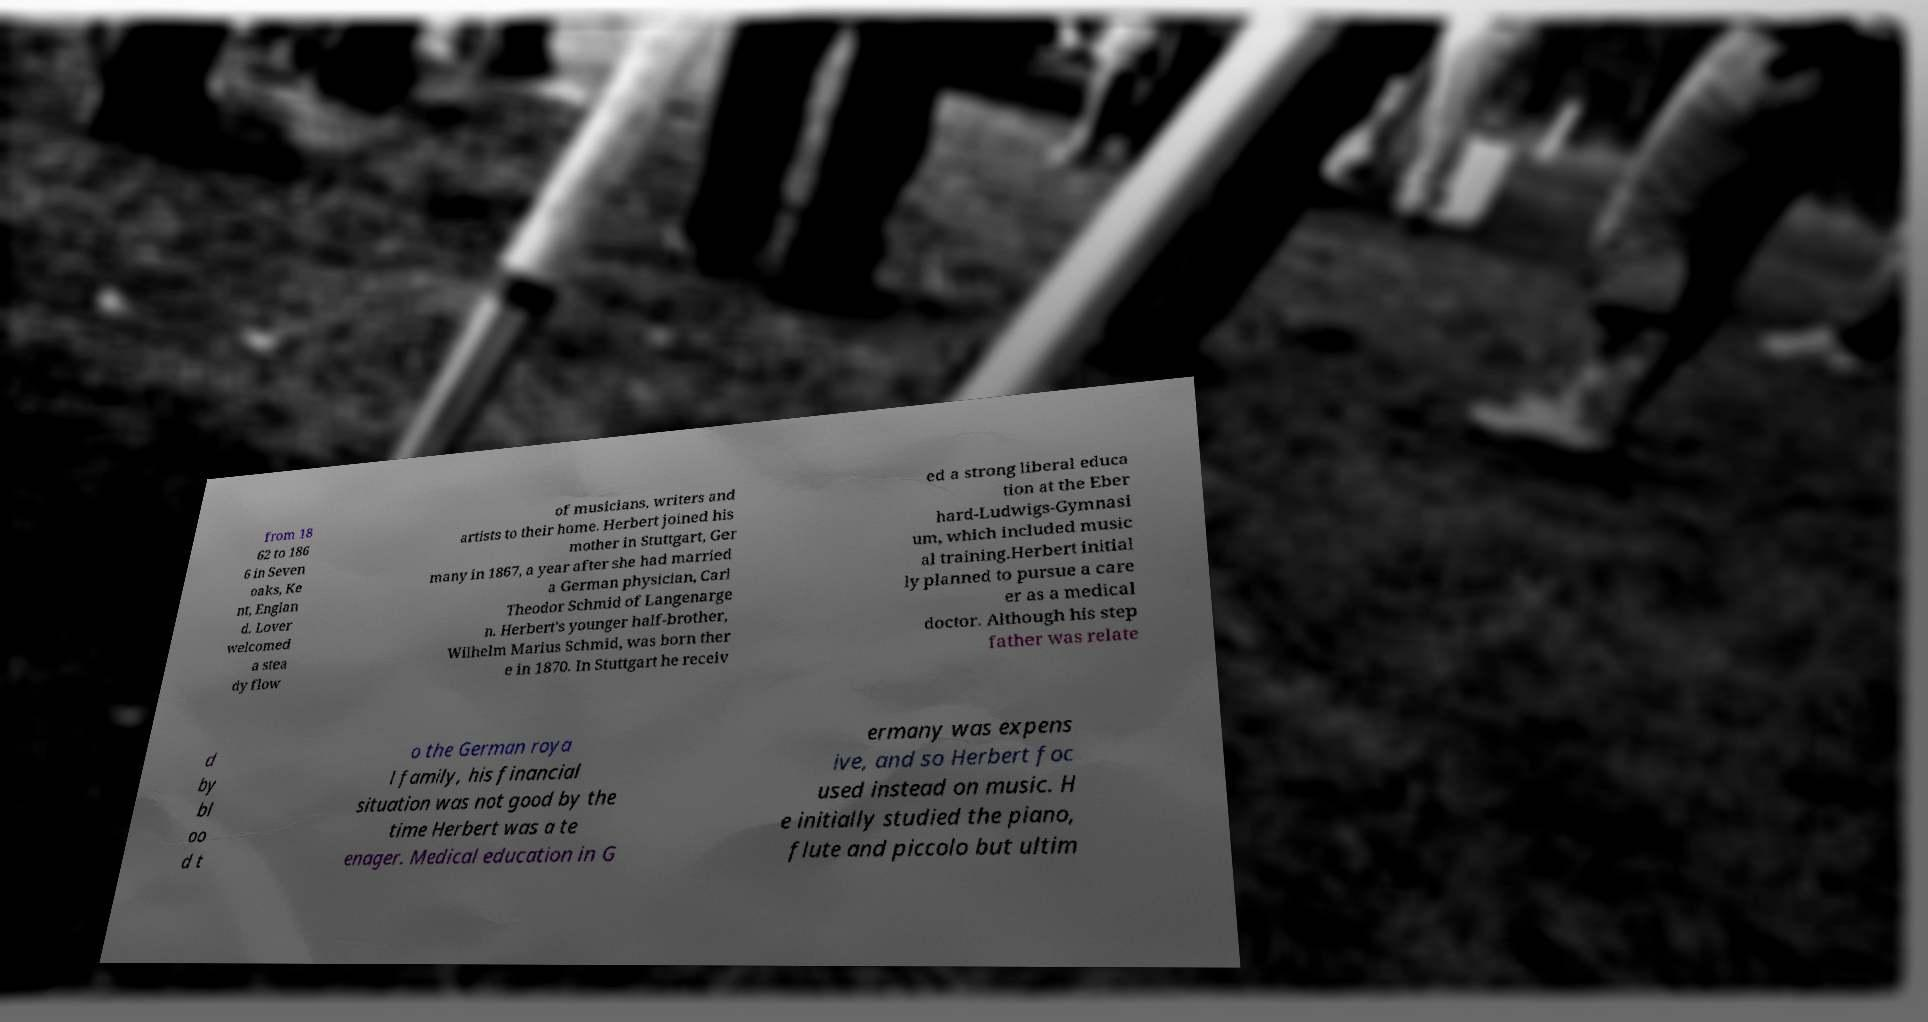What messages or text are displayed in this image? I need them in a readable, typed format. from 18 62 to 186 6 in Seven oaks, Ke nt, Englan d. Lover welcomed a stea dy flow of musicians, writers and artists to their home. Herbert joined his mother in Stuttgart, Ger many in 1867, a year after she had married a German physician, Carl Theodor Schmid of Langenarge n. Herbert's younger half-brother, Wilhelm Marius Schmid, was born ther e in 1870. In Stuttgart he receiv ed a strong liberal educa tion at the Eber hard-Ludwigs-Gymnasi um, which included music al training.Herbert initial ly planned to pursue a care er as a medical doctor. Although his step father was relate d by bl oo d t o the German roya l family, his financial situation was not good by the time Herbert was a te enager. Medical education in G ermany was expens ive, and so Herbert foc used instead on music. H e initially studied the piano, flute and piccolo but ultim 